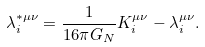<formula> <loc_0><loc_0><loc_500><loc_500>\lambda _ { i } ^ { \ast \mu \nu } = \frac { 1 } { 1 6 \pi G _ { N } } K _ { i } ^ { \mu \nu } - \lambda _ { i } ^ { \mu \nu } .</formula> 